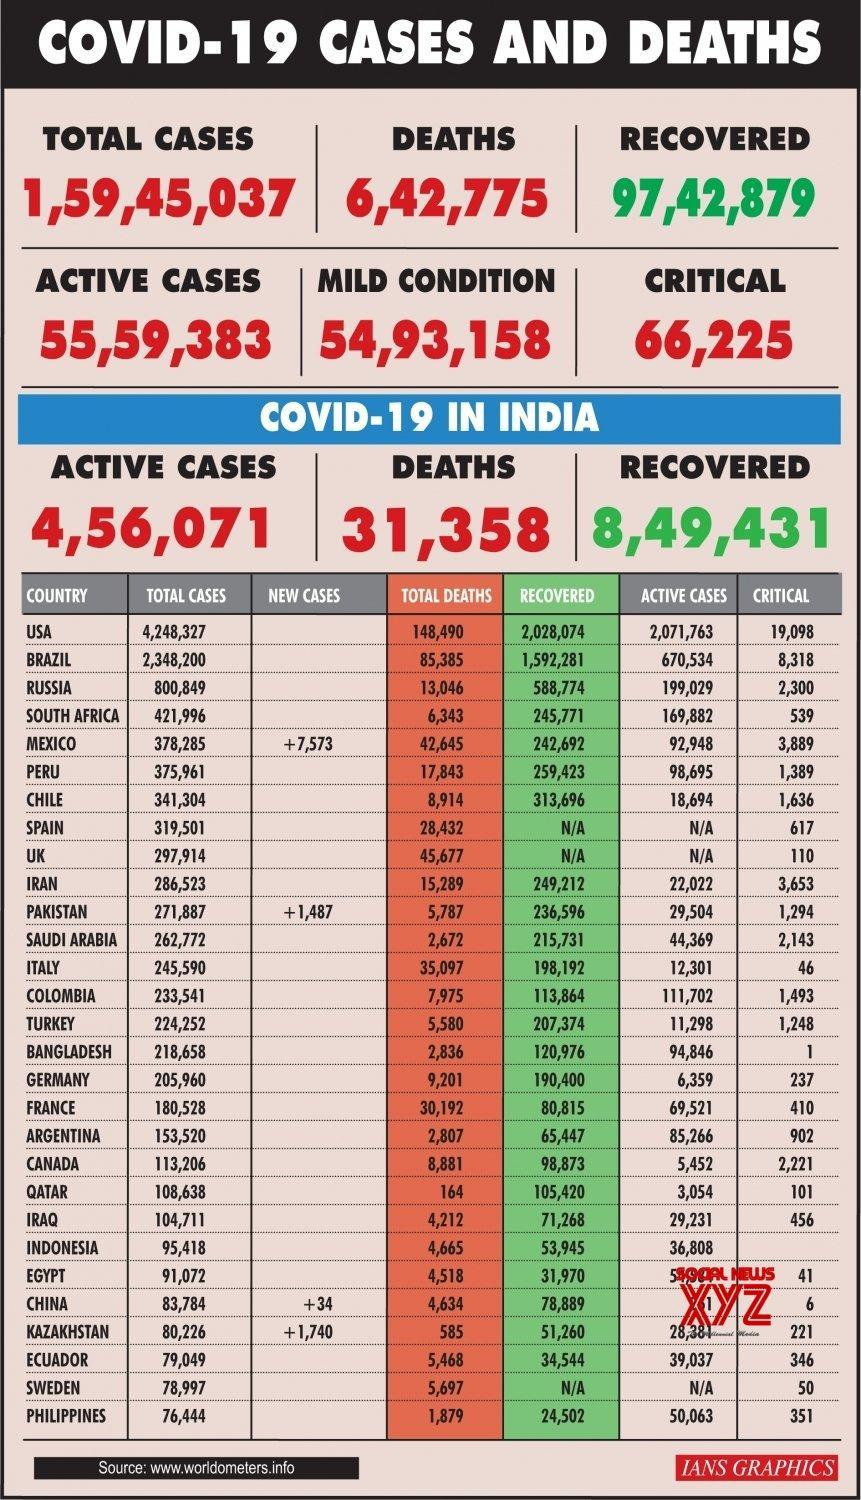How  many new COVID-19 cases were reported in Pakistan?
Answer the question with a short phrase. +1,487 How many recovered cases of covid-19 were reported in Russia? 588,774 How many active COVID-19 cases were reported in India? 4,56,071 Which country has reported the least number of COVID-19 cases globally? PHILIPPINES Which country has reported the highest number of COVID-19 cases globally? USA What is the total number of COVID-19 deaths reported in Italy? 35,097 How many active COVID-19 cases were reported critical in France? 410 How many active COVID-19 cases were reported critical globally? 66,225 What is the total number of COVID-19 deaths reported globally? 6,42,775 What is the number of COVID-19 deaths in India as per the given data? 31,358 